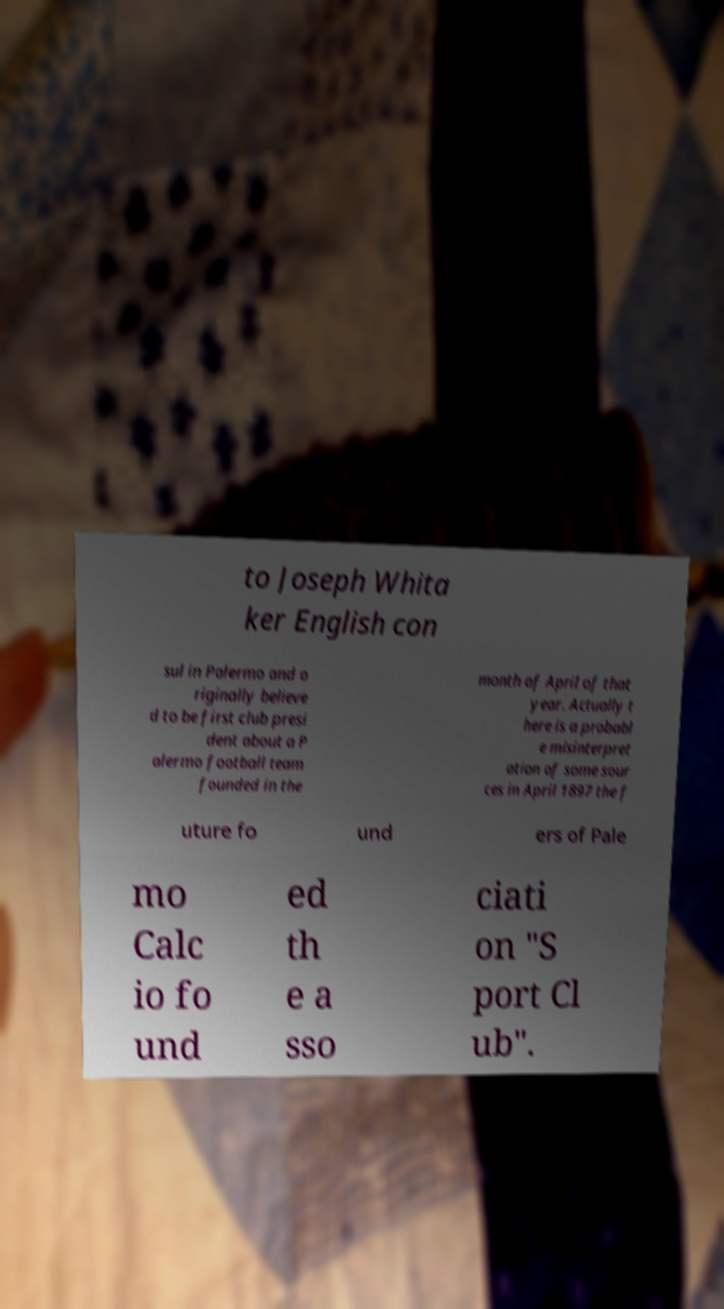Please identify and transcribe the text found in this image. to Joseph Whita ker English con sul in Palermo and o riginally believe d to be first club presi dent about a P alermo football team founded in the month of April of that year. Actually t here is a probabl e misinterpret ation of some sour ces in April 1897 the f uture fo und ers of Pale mo Calc io fo und ed th e a sso ciati on "S port Cl ub". 